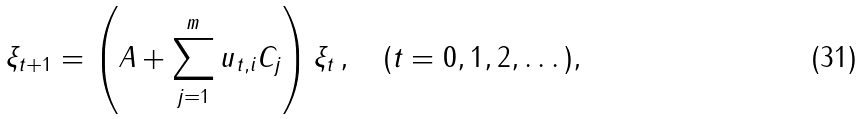<formula> <loc_0><loc_0><loc_500><loc_500>\xi _ { t + 1 } = \left ( A + \sum _ { j = 1 } ^ { m } u _ { t , i } C _ { j } \right ) \xi _ { t } \, , \quad ( t = 0 , 1 , 2 , \dots ) ,</formula> 